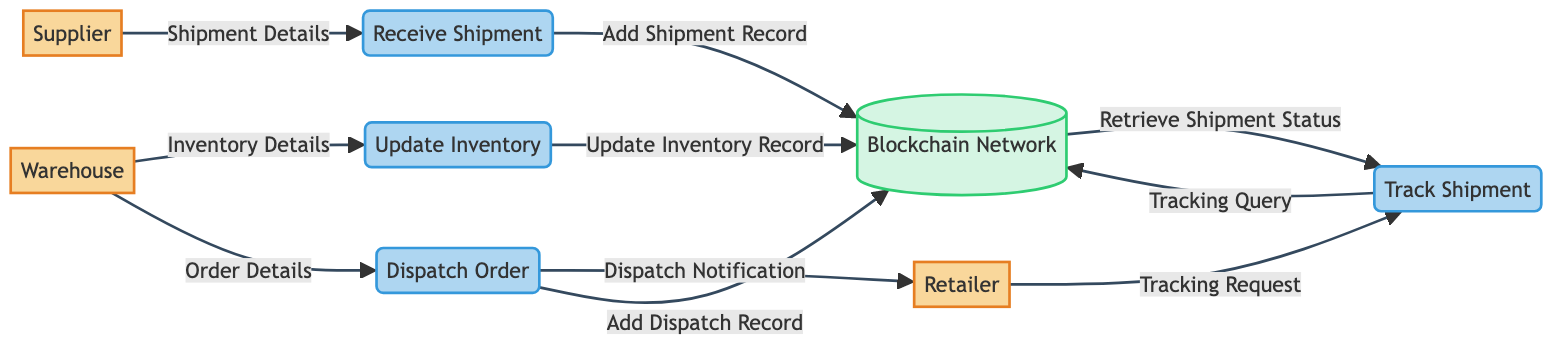What are the external entities in this diagram? The external entities are listed directly in the diagram. They include the Supplier, Warehouse, and Retailer.
Answer: Supplier, Warehouse, Retailer How many processes are there in total? The diagram contains four processes: Receive Shipment, Update Inventory, Dispatch Order, and Track Shipment. Adding these processes gives a total of four.
Answer: Four What data does the Supplier send to the Receive Shipment process? The diagram specifies that the Supplier sends "Shipment Details" to the Receive Shipment process. This can be directly identified from the data flow described.
Answer: Shipment Details What does the Update Inventory process output to the Blockchain Network? The Update Inventory process outputs "Update Inventory Record" to the Blockchain Network, which is stated in the data flow from Update Inventory to Blockchain Network.
Answer: Update Inventory Record What is the relationship between the Warehouse and the Dispatch Order process? The Warehouse provides "Order Details" to the Dispatch Order process, as indicated by the data flow from Warehouse to Dispatch Order.
Answer: Order Details How does the Retailer track a shipment? The Retailer sends a "Tracking Request" to the Track Shipment process, which is shown as a data flow from Retailer to Track Shipment. This request is then processed to retrieve shipment status.
Answer: Tracking Request What type of data does the Dispatch Order process send to the Blockchain Network? The Dispatch Order process sends "Add Dispatch Record" to the Blockchain Network, which is listed as one of the process outputs.
Answer: Add Dispatch Record What is the output of the Track Shipment process? The output from the Track Shipment process is "Retrieve Shipment Status", which is outlined as the information sent back from the Blockchain Network to the Track Shipment process.
Answer: Retrieve Shipment Status How many data flows are there in total? To find the total number of data flows, we count each connection defined in the diagram. There are ten data flows represented in the diagram.
Answer: Ten 